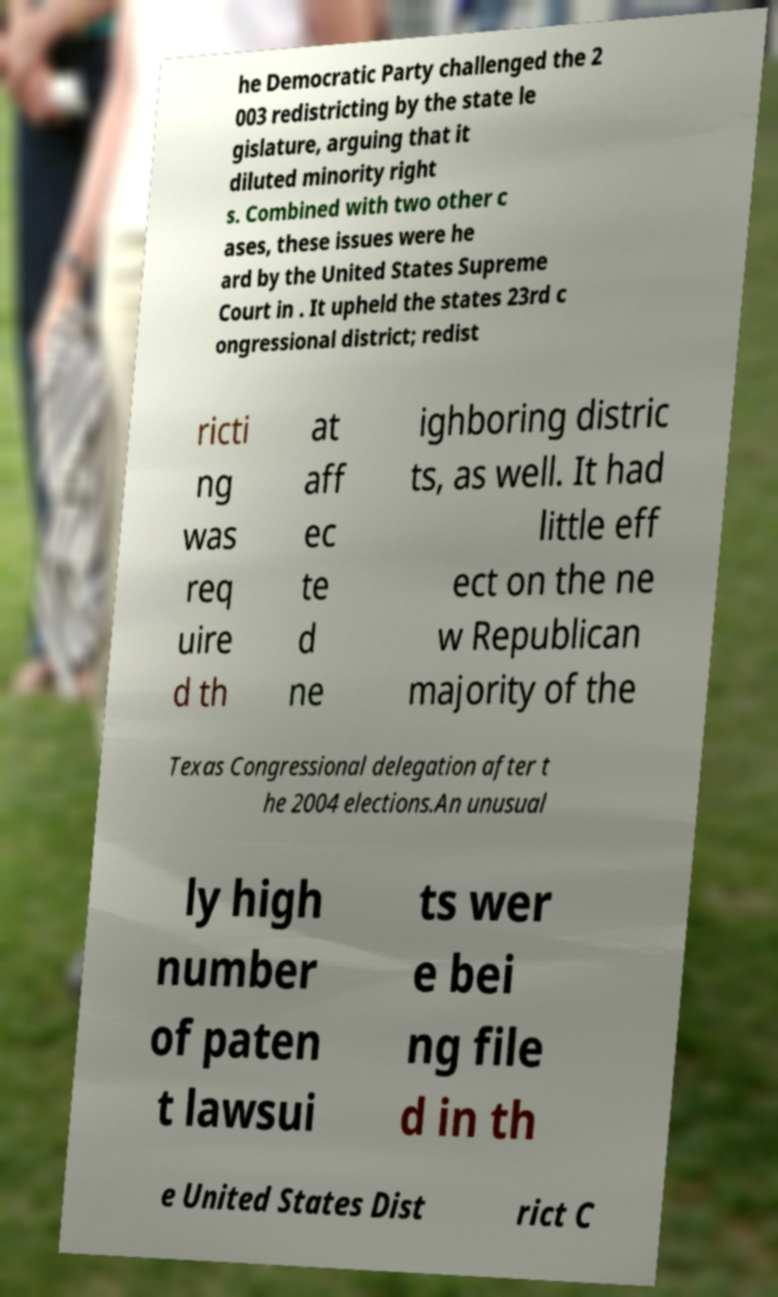I need the written content from this picture converted into text. Can you do that? he Democratic Party challenged the 2 003 redistricting by the state le gislature, arguing that it diluted minority right s. Combined with two other c ases, these issues were he ard by the United States Supreme Court in . It upheld the states 23rd c ongressional district; redist ricti ng was req uire d th at aff ec te d ne ighboring distric ts, as well. It had little eff ect on the ne w Republican majority of the Texas Congressional delegation after t he 2004 elections.An unusual ly high number of paten t lawsui ts wer e bei ng file d in th e United States Dist rict C 